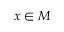<formula> <loc_0><loc_0><loc_500><loc_500>x \in M</formula> 